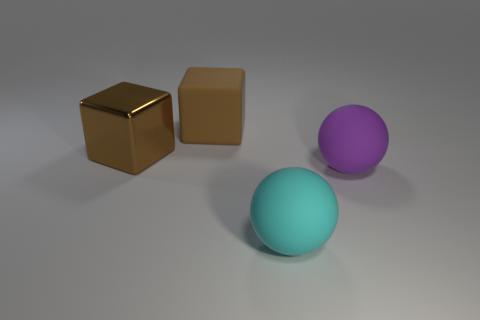What can be inferred about the surface the objects are resting on? The surface under the objects appears smooth and lightly reflective, indicating it could be a polished stone or a treated wooden surface. The evenness of the surface texture and subtle reflections lend an elegant quality to the overall aesthetics of the scene. Does the texture of the surface affect the appearance of the objects' shadows? Absolutely, the smoothness of the surface allows the shadows of the objects to be soft and diffuse. A rougher texture would scatter light more, leading to shadows that might appear more blurred and less defined. 